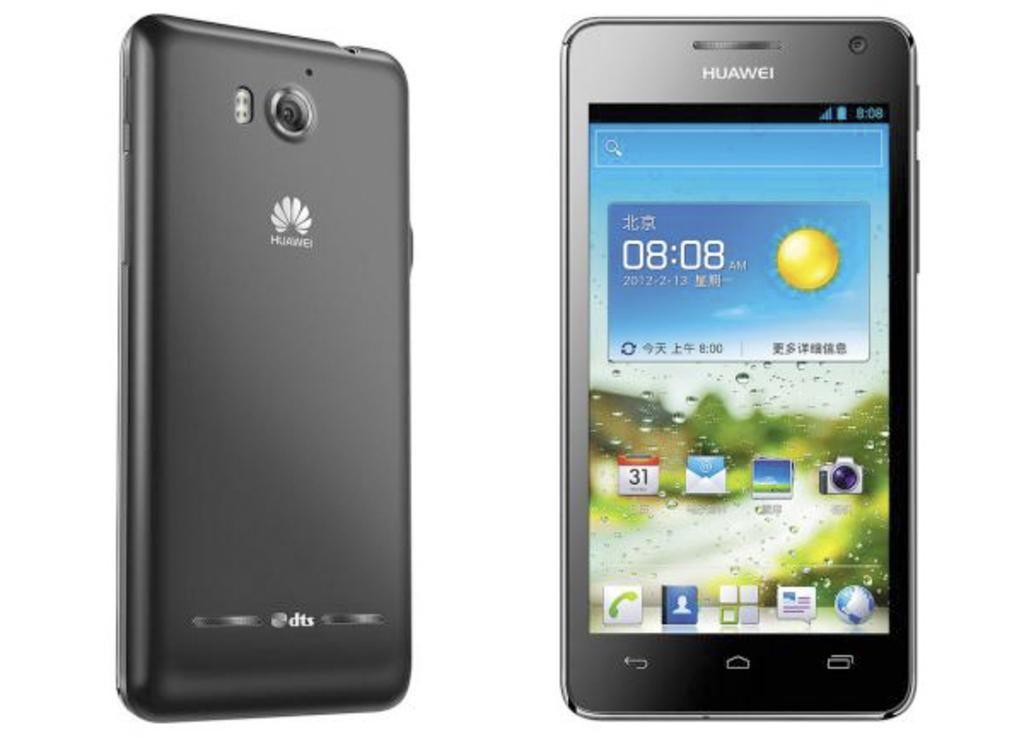Provide a one-sentence caption for the provided image. An ad showing the front and back of a HUAWEI cellphone. 